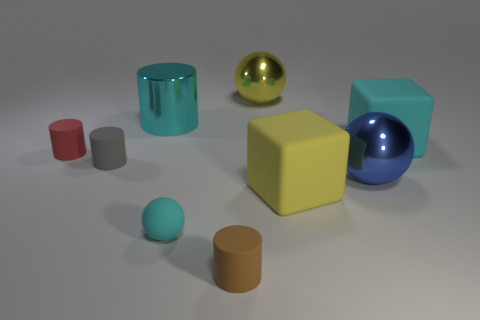Subtract 1 cylinders. How many cylinders are left? 3 Subtract all blocks. How many objects are left? 7 Subtract 0 red cubes. How many objects are left? 9 Subtract all red cylinders. Subtract all large balls. How many objects are left? 6 Add 9 red things. How many red things are left? 10 Add 2 small cyan objects. How many small cyan objects exist? 3 